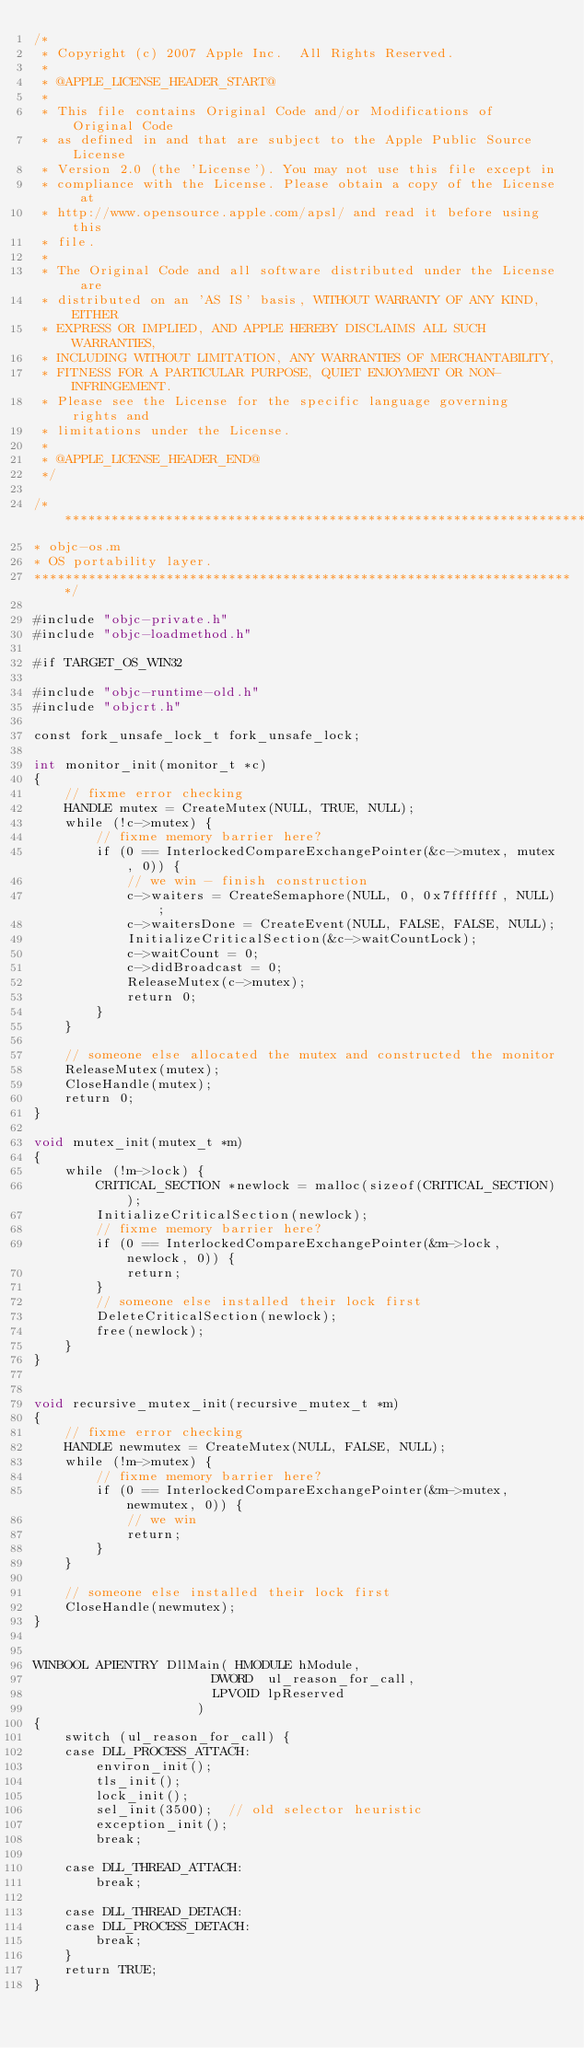<code> <loc_0><loc_0><loc_500><loc_500><_ObjectiveC_>/*
 * Copyright (c) 2007 Apple Inc.  All Rights Reserved.
 * 
 * @APPLE_LICENSE_HEADER_START@
 * 
 * This file contains Original Code and/or Modifications of Original Code
 * as defined in and that are subject to the Apple Public Source License
 * Version 2.0 (the 'License'). You may not use this file except in
 * compliance with the License. Please obtain a copy of the License at
 * http://www.opensource.apple.com/apsl/ and read it before using this
 * file.
 * 
 * The Original Code and all software distributed under the License are
 * distributed on an 'AS IS' basis, WITHOUT WARRANTY OF ANY KIND, EITHER
 * EXPRESS OR IMPLIED, AND APPLE HEREBY DISCLAIMS ALL SUCH WARRANTIES,
 * INCLUDING WITHOUT LIMITATION, ANY WARRANTIES OF MERCHANTABILITY,
 * FITNESS FOR A PARTICULAR PURPOSE, QUIET ENJOYMENT OR NON-INFRINGEMENT.
 * Please see the License for the specific language governing rights and
 * limitations under the License.
 * 
 * @APPLE_LICENSE_HEADER_END@
 */

/***********************************************************************
* objc-os.m
* OS portability layer.
**********************************************************************/

#include "objc-private.h"
#include "objc-loadmethod.h"

#if TARGET_OS_WIN32

#include "objc-runtime-old.h"
#include "objcrt.h"

const fork_unsafe_lock_t fork_unsafe_lock;

int monitor_init(monitor_t *c) 
{
    // fixme error checking
    HANDLE mutex = CreateMutex(NULL, TRUE, NULL);
    while (!c->mutex) {
        // fixme memory barrier here?
        if (0 == InterlockedCompareExchangePointer(&c->mutex, mutex, 0)) {
            // we win - finish construction
            c->waiters = CreateSemaphore(NULL, 0, 0x7fffffff, NULL);
            c->waitersDone = CreateEvent(NULL, FALSE, FALSE, NULL);
            InitializeCriticalSection(&c->waitCountLock);
            c->waitCount = 0;
            c->didBroadcast = 0;
            ReleaseMutex(c->mutex);    
            return 0;
        }
    }

    // someone else allocated the mutex and constructed the monitor
    ReleaseMutex(mutex);
    CloseHandle(mutex);
    return 0;
}

void mutex_init(mutex_t *m)
{
    while (!m->lock) {
        CRITICAL_SECTION *newlock = malloc(sizeof(CRITICAL_SECTION));
        InitializeCriticalSection(newlock);
        // fixme memory barrier here?
        if (0 == InterlockedCompareExchangePointer(&m->lock, newlock, 0)) {
            return;
        }
        // someone else installed their lock first
        DeleteCriticalSection(newlock);
        free(newlock);
    }
}


void recursive_mutex_init(recursive_mutex_t *m)
{
    // fixme error checking
    HANDLE newmutex = CreateMutex(NULL, FALSE, NULL);
    while (!m->mutex) {
        // fixme memory barrier here?
        if (0 == InterlockedCompareExchangePointer(&m->mutex, newmutex, 0)) {
            // we win
            return;
        }
    }
    
    // someone else installed their lock first
    CloseHandle(newmutex);
}


WINBOOL APIENTRY DllMain( HMODULE hModule,
                       DWORD  ul_reason_for_call,
                       LPVOID lpReserved
					 )
{
    switch (ul_reason_for_call) {
    case DLL_PROCESS_ATTACH:
        environ_init();
        tls_init();
        lock_init();
        sel_init(3500);  // old selector heuristic
        exception_init();
        break;

    case DLL_THREAD_ATTACH:
        break;

    case DLL_THREAD_DETACH:
    case DLL_PROCESS_DETACH:
        break;
    }
    return TRUE;
}
</code> 